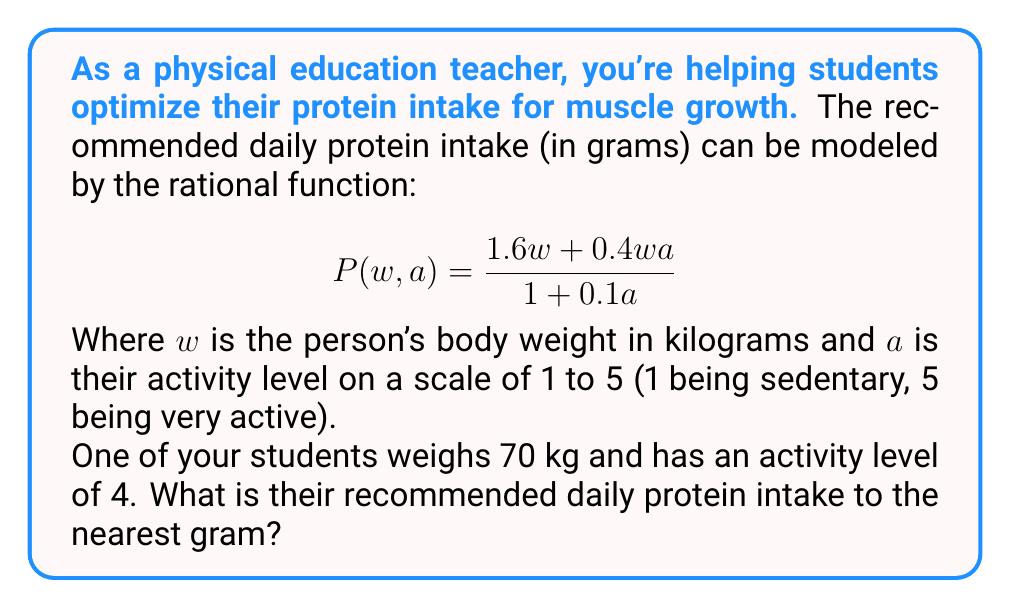Teach me how to tackle this problem. Let's approach this step-by-step:

1) We're given the rational function for protein intake:
   $$P(w, a) = \frac{1.6w + 0.4wa}{1 + 0.1a}$$

2) We know the student's weight (w) and activity level (a):
   $w = 70$ kg
   $a = 4$

3) Let's substitute these values into our function:
   $$P(70, 4) = \frac{1.6(70) + 0.4(70)(4)}{1 + 0.1(4)}$$

4) Let's simplify the numerator:
   $1.6(70) = 112$
   $0.4(70)(4) = 112$
   $112 + 112 = 224$

5) Now the denominator:
   $1 + 0.1(4) = 1 + 0.4 = 1.4$

6) Our equation now looks like:
   $$P(70, 4) = \frac{224}{1.4}$$

7) Dividing:
   $224 ÷ 1.4 = 160$

8) Rounding to the nearest gram:
   $160$ grams
Answer: 160 grams 